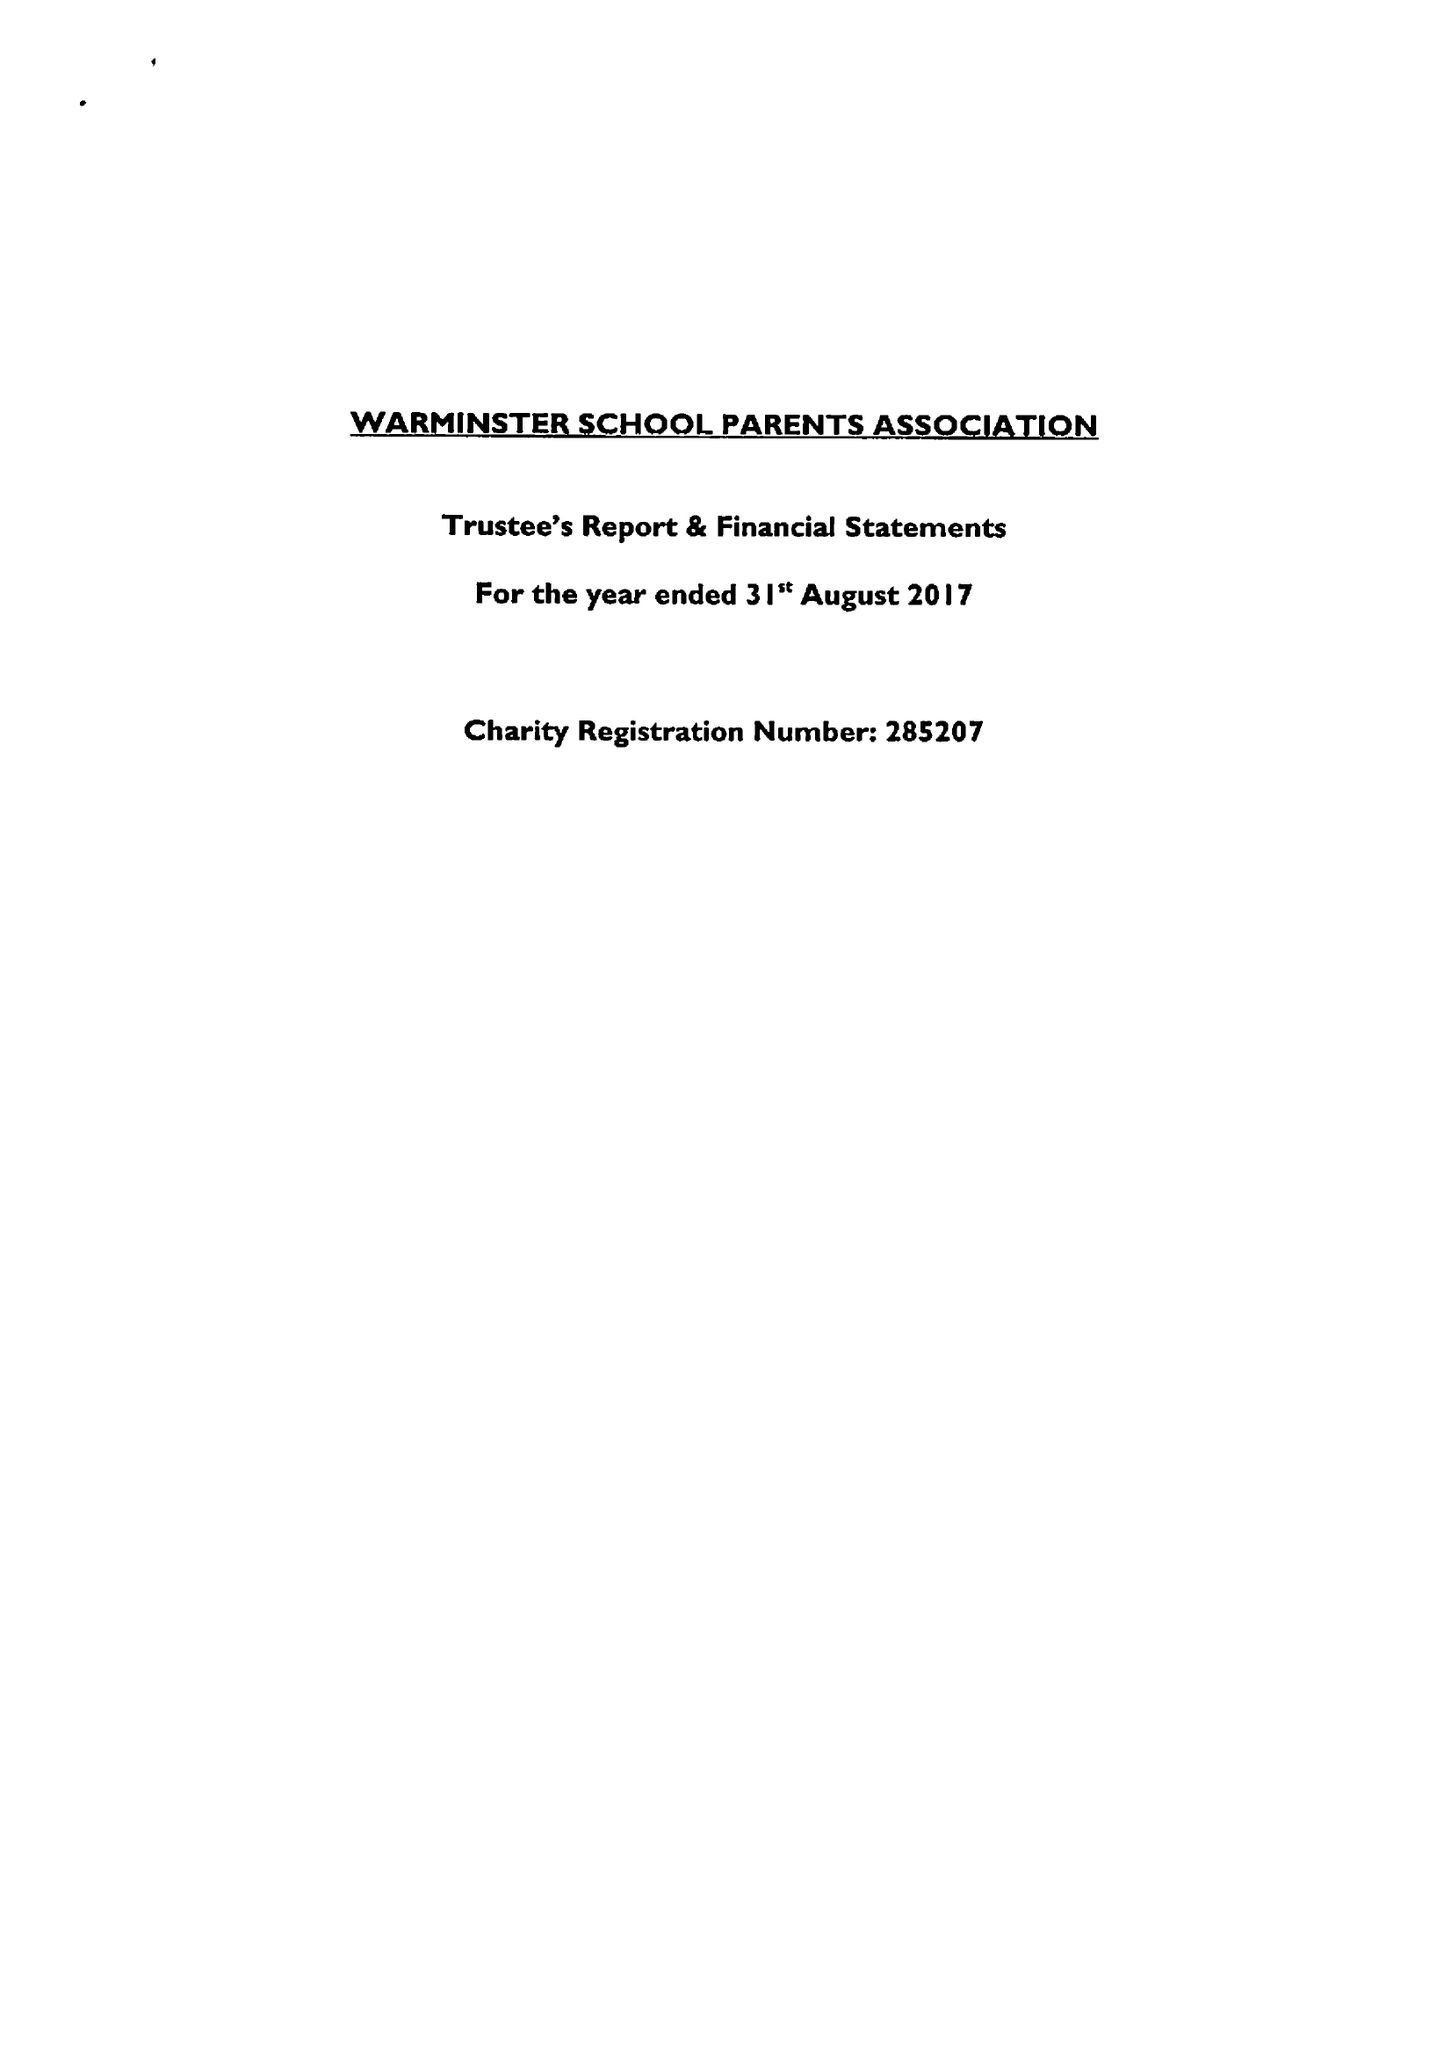What is the value for the report_date?
Answer the question using a single word or phrase. 2017-08-31 